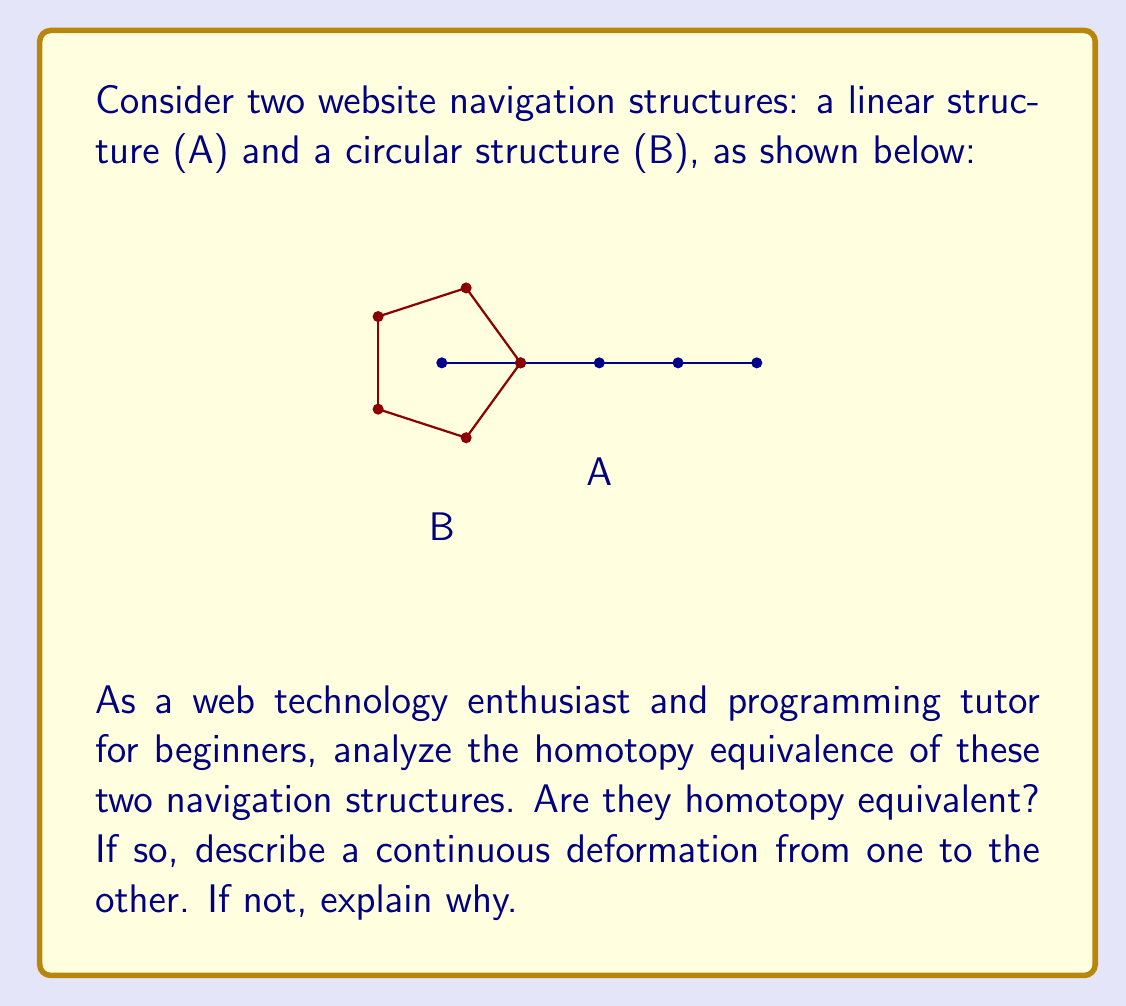Solve this math problem. To determine if the two navigation structures are homotopy equivalent, we need to consider if one can be continuously deformed into the other without breaking or gluing.

Step 1: Analyze structure A (linear)
- Structure A is topologically equivalent to a line segment.
- It has two distinct endpoints.

Step 2: Analyze structure B (circular)
- Structure B is topologically equivalent to a circle.
- It has no endpoints; all points are connected in a loop.

Step 3: Compare the fundamental properties
- The key difference is that structure A has endpoints, while B does not.
- In topology, the presence or absence of endpoints is a crucial property that cannot be changed through continuous deformation.

Step 4: Consider possible deformations
- We cannot create or remove endpoints through continuous deformation.
- It's impossible to transform A into B (or vice versa) without either:
  a) Breaking the circle (which is not a continuous deformation)
  b) Joining the endpoints of the line (which is not a continuous deformation)

Step 5: Conclusion
- Since we cannot transform one structure into the other through continuous deformation, they are not homotopy equivalent.

In the context of web navigation:
- Structure A represents a linear navigation path (e.g., a step-by-step tutorial)
- Structure B represents a circular navigation path (e.g., a menu that loops back to the start)

These fundamentally different navigation patterns cannot be smoothly transformed into each other without significantly altering the user experience, which aligns with their topological non-equivalence.
Answer: Not homotopy equivalent 